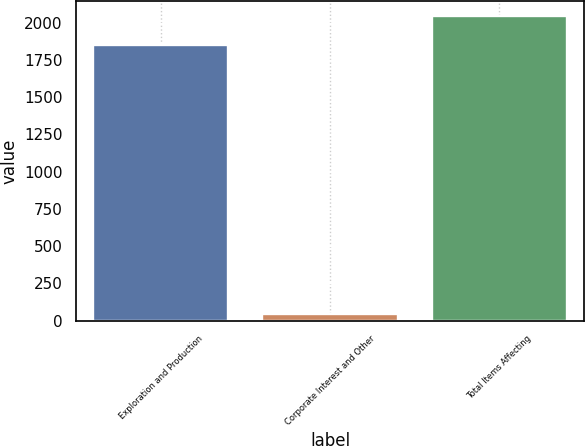Convert chart to OTSL. <chart><loc_0><loc_0><loc_500><loc_500><bar_chart><fcel>Exploration and Production<fcel>Corporate Interest and Other<fcel>Total Items Affecting<nl><fcel>1851<fcel>44<fcel>2040.9<nl></chart> 